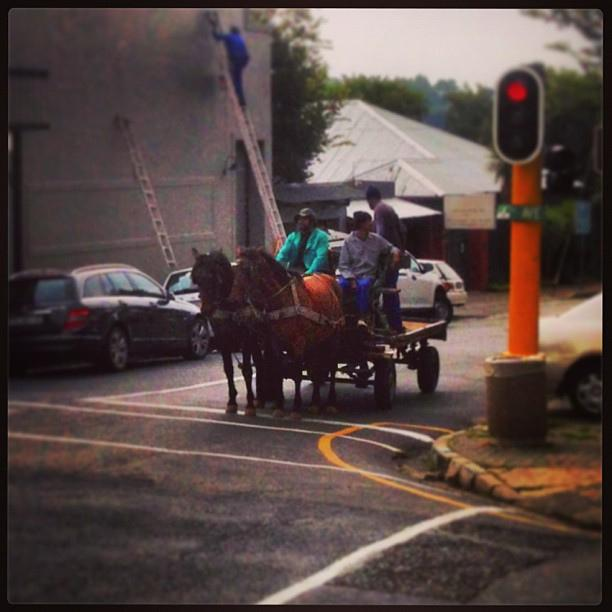What color is the big horse to the right with the flat cart behind it? brown 